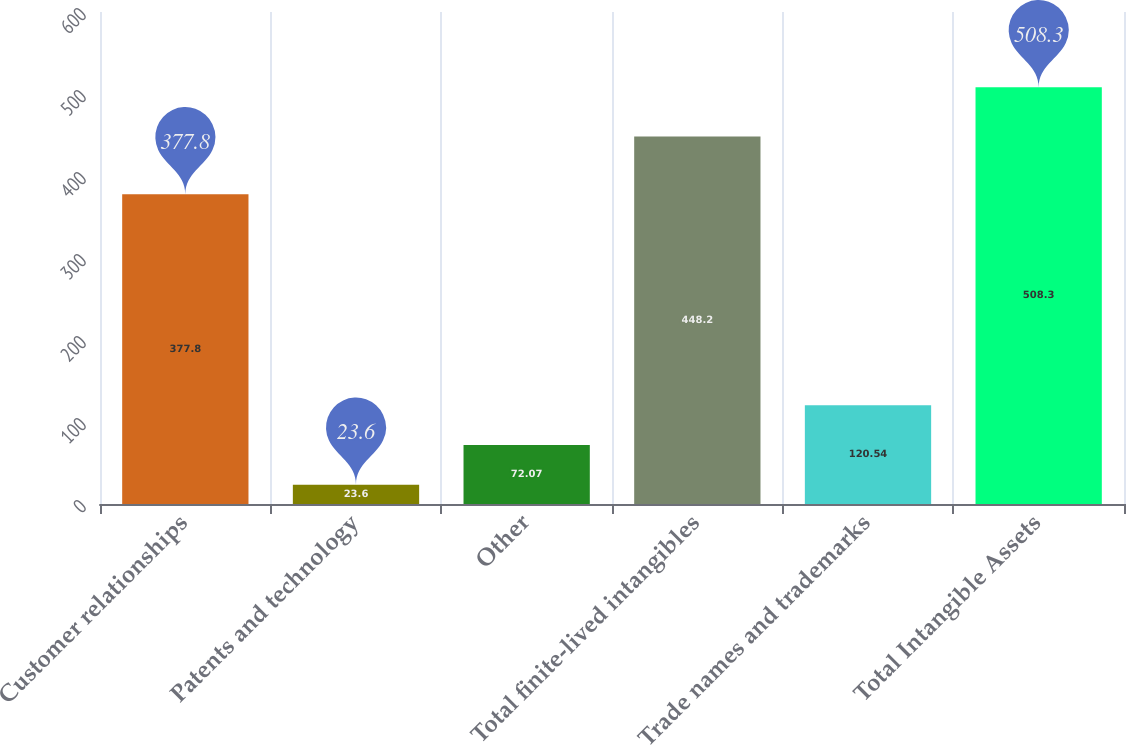<chart> <loc_0><loc_0><loc_500><loc_500><bar_chart><fcel>Customer relationships<fcel>Patents and technology<fcel>Other<fcel>Total finite-lived intangibles<fcel>Trade names and trademarks<fcel>Total Intangible Assets<nl><fcel>377.8<fcel>23.6<fcel>72.07<fcel>448.2<fcel>120.54<fcel>508.3<nl></chart> 